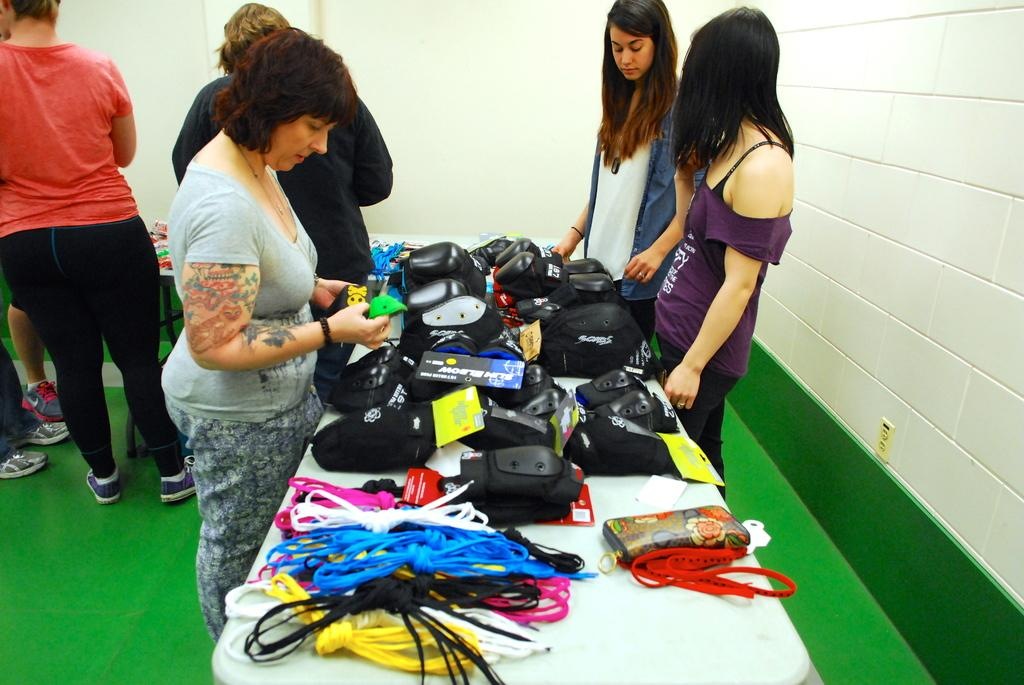What is the color of the tables in the image? The tables in the image are white. What can be seen on the tables? There are objects on the white tables. What is the appearance of the people in the image? People are standing in the image. What type of surface is visible in the image? There is a green surface in the image. What is the color of the walls in the image? White walls are present in the image. How many eyes can be seen on the forks in the image? There are no forks present in the image, and therefore no eyes can be seen on them. 